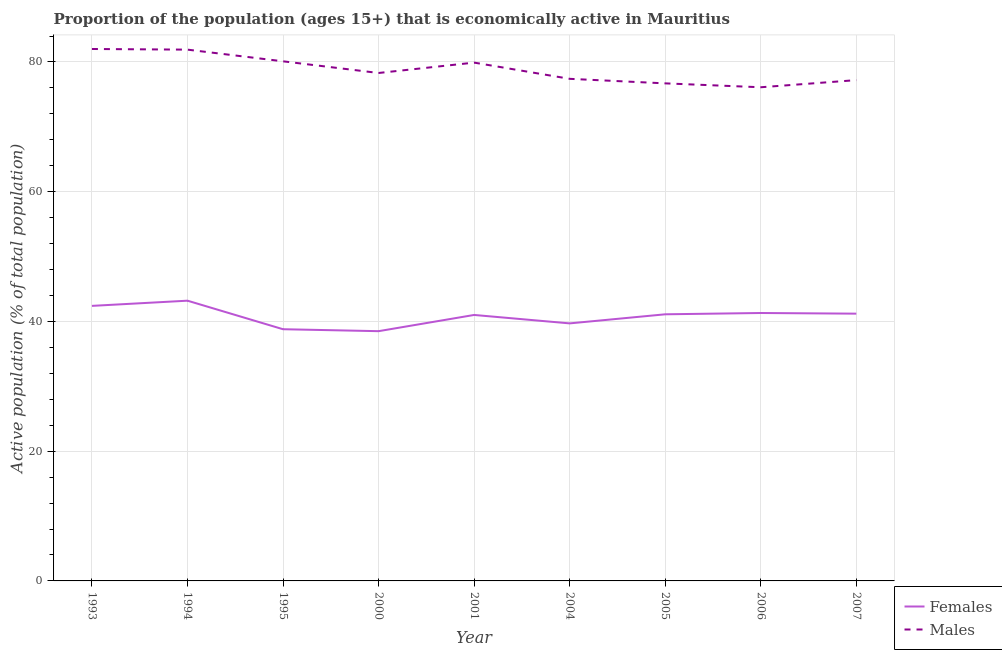How many different coloured lines are there?
Ensure brevity in your answer.  2. Is the number of lines equal to the number of legend labels?
Your response must be concise. Yes. Across all years, what is the minimum percentage of economically active male population?
Your answer should be very brief. 76.1. What is the total percentage of economically active male population in the graph?
Offer a very short reply. 709.6. What is the difference between the percentage of economically active female population in 1995 and that in 2001?
Give a very brief answer. -2.2. What is the difference between the percentage of economically active female population in 2004 and the percentage of economically active male population in 1995?
Your answer should be very brief. -40.4. What is the average percentage of economically active male population per year?
Provide a short and direct response. 78.84. In the year 2001, what is the difference between the percentage of economically active male population and percentage of economically active female population?
Offer a terse response. 38.9. In how many years, is the percentage of economically active male population greater than 40 %?
Your answer should be very brief. 9. What is the ratio of the percentage of economically active male population in 1994 to that in 2006?
Your answer should be compact. 1.08. What is the difference between the highest and the second highest percentage of economically active male population?
Your answer should be very brief. 0.1. What is the difference between the highest and the lowest percentage of economically active female population?
Make the answer very short. 4.7. Is the sum of the percentage of economically active male population in 2004 and 2007 greater than the maximum percentage of economically active female population across all years?
Your answer should be compact. Yes. Does the percentage of economically active male population monotonically increase over the years?
Offer a very short reply. No. Is the percentage of economically active female population strictly less than the percentage of economically active male population over the years?
Provide a short and direct response. Yes. How many lines are there?
Your answer should be compact. 2. Does the graph contain any zero values?
Provide a succinct answer. No. Does the graph contain grids?
Your answer should be compact. Yes. Where does the legend appear in the graph?
Provide a succinct answer. Bottom right. How many legend labels are there?
Your response must be concise. 2. What is the title of the graph?
Make the answer very short. Proportion of the population (ages 15+) that is economically active in Mauritius. What is the label or title of the X-axis?
Provide a succinct answer. Year. What is the label or title of the Y-axis?
Offer a very short reply. Active population (% of total population). What is the Active population (% of total population) in Females in 1993?
Give a very brief answer. 42.4. What is the Active population (% of total population) in Males in 1993?
Your answer should be very brief. 82. What is the Active population (% of total population) in Females in 1994?
Make the answer very short. 43.2. What is the Active population (% of total population) in Males in 1994?
Your answer should be very brief. 81.9. What is the Active population (% of total population) in Females in 1995?
Offer a very short reply. 38.8. What is the Active population (% of total population) in Males in 1995?
Provide a short and direct response. 80.1. What is the Active population (% of total population) of Females in 2000?
Make the answer very short. 38.5. What is the Active population (% of total population) of Males in 2000?
Your response must be concise. 78.3. What is the Active population (% of total population) in Females in 2001?
Your answer should be very brief. 41. What is the Active population (% of total population) of Males in 2001?
Give a very brief answer. 79.9. What is the Active population (% of total population) in Females in 2004?
Your answer should be compact. 39.7. What is the Active population (% of total population) of Males in 2004?
Your answer should be very brief. 77.4. What is the Active population (% of total population) of Females in 2005?
Keep it short and to the point. 41.1. What is the Active population (% of total population) of Males in 2005?
Offer a very short reply. 76.7. What is the Active population (% of total population) in Females in 2006?
Give a very brief answer. 41.3. What is the Active population (% of total population) of Males in 2006?
Give a very brief answer. 76.1. What is the Active population (% of total population) in Females in 2007?
Give a very brief answer. 41.2. What is the Active population (% of total population) in Males in 2007?
Offer a terse response. 77.2. Across all years, what is the maximum Active population (% of total population) of Females?
Make the answer very short. 43.2. Across all years, what is the minimum Active population (% of total population) of Females?
Ensure brevity in your answer.  38.5. Across all years, what is the minimum Active population (% of total population) in Males?
Make the answer very short. 76.1. What is the total Active population (% of total population) of Females in the graph?
Offer a terse response. 367.2. What is the total Active population (% of total population) of Males in the graph?
Keep it short and to the point. 709.6. What is the difference between the Active population (% of total population) of Males in 1993 and that in 1994?
Your answer should be very brief. 0.1. What is the difference between the Active population (% of total population) of Females in 1993 and that in 1995?
Offer a terse response. 3.6. What is the difference between the Active population (% of total population) in Males in 1993 and that in 1995?
Ensure brevity in your answer.  1.9. What is the difference between the Active population (% of total population) of Males in 1993 and that in 2000?
Your response must be concise. 3.7. What is the difference between the Active population (% of total population) of Males in 1993 and that in 2006?
Make the answer very short. 5.9. What is the difference between the Active population (% of total population) in Males in 1994 and that in 1995?
Keep it short and to the point. 1.8. What is the difference between the Active population (% of total population) of Females in 1994 and that in 2001?
Make the answer very short. 2.2. What is the difference between the Active population (% of total population) in Females in 1994 and that in 2004?
Your answer should be compact. 3.5. What is the difference between the Active population (% of total population) in Females in 1994 and that in 2007?
Give a very brief answer. 2. What is the difference between the Active population (% of total population) of Males in 1994 and that in 2007?
Offer a very short reply. 4.7. What is the difference between the Active population (% of total population) of Males in 1995 and that in 2001?
Offer a very short reply. 0.2. What is the difference between the Active population (% of total population) in Females in 1995 and that in 2004?
Provide a short and direct response. -0.9. What is the difference between the Active population (% of total population) in Males in 1995 and that in 2005?
Offer a terse response. 3.4. What is the difference between the Active population (% of total population) in Females in 1995 and that in 2006?
Your response must be concise. -2.5. What is the difference between the Active population (% of total population) of Males in 1995 and that in 2006?
Ensure brevity in your answer.  4. What is the difference between the Active population (% of total population) of Females in 2000 and that in 2004?
Keep it short and to the point. -1.2. What is the difference between the Active population (% of total population) of Males in 2000 and that in 2005?
Your answer should be very brief. 1.6. What is the difference between the Active population (% of total population) in Females in 2000 and that in 2006?
Your answer should be compact. -2.8. What is the difference between the Active population (% of total population) of Males in 2000 and that in 2006?
Offer a very short reply. 2.2. What is the difference between the Active population (% of total population) of Females in 2001 and that in 2004?
Provide a short and direct response. 1.3. What is the difference between the Active population (% of total population) of Males in 2001 and that in 2004?
Provide a short and direct response. 2.5. What is the difference between the Active population (% of total population) of Females in 2001 and that in 2005?
Offer a very short reply. -0.1. What is the difference between the Active population (% of total population) of Males in 2001 and that in 2006?
Provide a succinct answer. 3.8. What is the difference between the Active population (% of total population) in Females in 2001 and that in 2007?
Offer a terse response. -0.2. What is the difference between the Active population (% of total population) in Males in 2001 and that in 2007?
Provide a short and direct response. 2.7. What is the difference between the Active population (% of total population) in Females in 2004 and that in 2007?
Offer a terse response. -1.5. What is the difference between the Active population (% of total population) in Males in 2004 and that in 2007?
Keep it short and to the point. 0.2. What is the difference between the Active population (% of total population) of Females in 2005 and that in 2006?
Give a very brief answer. -0.2. What is the difference between the Active population (% of total population) in Females in 2005 and that in 2007?
Keep it short and to the point. -0.1. What is the difference between the Active population (% of total population) of Females in 1993 and the Active population (% of total population) of Males in 1994?
Make the answer very short. -39.5. What is the difference between the Active population (% of total population) of Females in 1993 and the Active population (% of total population) of Males in 1995?
Keep it short and to the point. -37.7. What is the difference between the Active population (% of total population) of Females in 1993 and the Active population (% of total population) of Males in 2000?
Your response must be concise. -35.9. What is the difference between the Active population (% of total population) of Females in 1993 and the Active population (% of total population) of Males in 2001?
Provide a short and direct response. -37.5. What is the difference between the Active population (% of total population) of Females in 1993 and the Active population (% of total population) of Males in 2004?
Offer a terse response. -35. What is the difference between the Active population (% of total population) in Females in 1993 and the Active population (% of total population) in Males in 2005?
Keep it short and to the point. -34.3. What is the difference between the Active population (% of total population) in Females in 1993 and the Active population (% of total population) in Males in 2006?
Ensure brevity in your answer.  -33.7. What is the difference between the Active population (% of total population) in Females in 1993 and the Active population (% of total population) in Males in 2007?
Your response must be concise. -34.8. What is the difference between the Active population (% of total population) of Females in 1994 and the Active population (% of total population) of Males in 1995?
Offer a terse response. -36.9. What is the difference between the Active population (% of total population) in Females in 1994 and the Active population (% of total population) in Males in 2000?
Make the answer very short. -35.1. What is the difference between the Active population (% of total population) in Females in 1994 and the Active population (% of total population) in Males in 2001?
Your answer should be compact. -36.7. What is the difference between the Active population (% of total population) of Females in 1994 and the Active population (% of total population) of Males in 2004?
Give a very brief answer. -34.2. What is the difference between the Active population (% of total population) of Females in 1994 and the Active population (% of total population) of Males in 2005?
Your answer should be compact. -33.5. What is the difference between the Active population (% of total population) of Females in 1994 and the Active population (% of total population) of Males in 2006?
Give a very brief answer. -32.9. What is the difference between the Active population (% of total population) of Females in 1994 and the Active population (% of total population) of Males in 2007?
Provide a short and direct response. -34. What is the difference between the Active population (% of total population) of Females in 1995 and the Active population (% of total population) of Males in 2000?
Give a very brief answer. -39.5. What is the difference between the Active population (% of total population) in Females in 1995 and the Active population (% of total population) in Males in 2001?
Provide a short and direct response. -41.1. What is the difference between the Active population (% of total population) of Females in 1995 and the Active population (% of total population) of Males in 2004?
Offer a terse response. -38.6. What is the difference between the Active population (% of total population) in Females in 1995 and the Active population (% of total population) in Males in 2005?
Your answer should be compact. -37.9. What is the difference between the Active population (% of total population) in Females in 1995 and the Active population (% of total population) in Males in 2006?
Your answer should be compact. -37.3. What is the difference between the Active population (% of total population) of Females in 1995 and the Active population (% of total population) of Males in 2007?
Your answer should be very brief. -38.4. What is the difference between the Active population (% of total population) in Females in 2000 and the Active population (% of total population) in Males in 2001?
Keep it short and to the point. -41.4. What is the difference between the Active population (% of total population) of Females in 2000 and the Active population (% of total population) of Males in 2004?
Ensure brevity in your answer.  -38.9. What is the difference between the Active population (% of total population) in Females in 2000 and the Active population (% of total population) in Males in 2005?
Offer a very short reply. -38.2. What is the difference between the Active population (% of total population) of Females in 2000 and the Active population (% of total population) of Males in 2006?
Keep it short and to the point. -37.6. What is the difference between the Active population (% of total population) of Females in 2000 and the Active population (% of total population) of Males in 2007?
Your response must be concise. -38.7. What is the difference between the Active population (% of total population) in Females in 2001 and the Active population (% of total population) in Males in 2004?
Offer a very short reply. -36.4. What is the difference between the Active population (% of total population) of Females in 2001 and the Active population (% of total population) of Males in 2005?
Your answer should be compact. -35.7. What is the difference between the Active population (% of total population) in Females in 2001 and the Active population (% of total population) in Males in 2006?
Your answer should be very brief. -35.1. What is the difference between the Active population (% of total population) of Females in 2001 and the Active population (% of total population) of Males in 2007?
Offer a terse response. -36.2. What is the difference between the Active population (% of total population) in Females in 2004 and the Active population (% of total population) in Males in 2005?
Keep it short and to the point. -37. What is the difference between the Active population (% of total population) in Females in 2004 and the Active population (% of total population) in Males in 2006?
Keep it short and to the point. -36.4. What is the difference between the Active population (% of total population) of Females in 2004 and the Active population (% of total population) of Males in 2007?
Your answer should be very brief. -37.5. What is the difference between the Active population (% of total population) of Females in 2005 and the Active population (% of total population) of Males in 2006?
Your answer should be very brief. -35. What is the difference between the Active population (% of total population) of Females in 2005 and the Active population (% of total population) of Males in 2007?
Keep it short and to the point. -36.1. What is the difference between the Active population (% of total population) in Females in 2006 and the Active population (% of total population) in Males in 2007?
Make the answer very short. -35.9. What is the average Active population (% of total population) in Females per year?
Offer a very short reply. 40.8. What is the average Active population (% of total population) in Males per year?
Your answer should be very brief. 78.84. In the year 1993, what is the difference between the Active population (% of total population) of Females and Active population (% of total population) of Males?
Your answer should be very brief. -39.6. In the year 1994, what is the difference between the Active population (% of total population) of Females and Active population (% of total population) of Males?
Keep it short and to the point. -38.7. In the year 1995, what is the difference between the Active population (% of total population) in Females and Active population (% of total population) in Males?
Your response must be concise. -41.3. In the year 2000, what is the difference between the Active population (% of total population) of Females and Active population (% of total population) of Males?
Provide a short and direct response. -39.8. In the year 2001, what is the difference between the Active population (% of total population) in Females and Active population (% of total population) in Males?
Offer a very short reply. -38.9. In the year 2004, what is the difference between the Active population (% of total population) in Females and Active population (% of total population) in Males?
Your answer should be very brief. -37.7. In the year 2005, what is the difference between the Active population (% of total population) in Females and Active population (% of total population) in Males?
Offer a terse response. -35.6. In the year 2006, what is the difference between the Active population (% of total population) in Females and Active population (% of total population) in Males?
Offer a terse response. -34.8. In the year 2007, what is the difference between the Active population (% of total population) in Females and Active population (% of total population) in Males?
Offer a very short reply. -36. What is the ratio of the Active population (% of total population) of Females in 1993 to that in 1994?
Give a very brief answer. 0.98. What is the ratio of the Active population (% of total population) in Females in 1993 to that in 1995?
Provide a short and direct response. 1.09. What is the ratio of the Active population (% of total population) of Males in 1993 to that in 1995?
Provide a succinct answer. 1.02. What is the ratio of the Active population (% of total population) of Females in 1993 to that in 2000?
Your answer should be compact. 1.1. What is the ratio of the Active population (% of total population) of Males in 1993 to that in 2000?
Offer a very short reply. 1.05. What is the ratio of the Active population (% of total population) of Females in 1993 to that in 2001?
Offer a terse response. 1.03. What is the ratio of the Active population (% of total population) of Males in 1993 to that in 2001?
Your answer should be compact. 1.03. What is the ratio of the Active population (% of total population) of Females in 1993 to that in 2004?
Provide a succinct answer. 1.07. What is the ratio of the Active population (% of total population) in Males in 1993 to that in 2004?
Provide a succinct answer. 1.06. What is the ratio of the Active population (% of total population) in Females in 1993 to that in 2005?
Offer a terse response. 1.03. What is the ratio of the Active population (% of total population) of Males in 1993 to that in 2005?
Offer a terse response. 1.07. What is the ratio of the Active population (% of total population) in Females in 1993 to that in 2006?
Keep it short and to the point. 1.03. What is the ratio of the Active population (% of total population) of Males in 1993 to that in 2006?
Your response must be concise. 1.08. What is the ratio of the Active population (% of total population) of Females in 1993 to that in 2007?
Your answer should be compact. 1.03. What is the ratio of the Active population (% of total population) of Males in 1993 to that in 2007?
Ensure brevity in your answer.  1.06. What is the ratio of the Active population (% of total population) in Females in 1994 to that in 1995?
Provide a short and direct response. 1.11. What is the ratio of the Active population (% of total population) in Males in 1994 to that in 1995?
Your answer should be compact. 1.02. What is the ratio of the Active population (% of total population) of Females in 1994 to that in 2000?
Provide a short and direct response. 1.12. What is the ratio of the Active population (% of total population) in Males in 1994 to that in 2000?
Give a very brief answer. 1.05. What is the ratio of the Active population (% of total population) of Females in 1994 to that in 2001?
Your response must be concise. 1.05. What is the ratio of the Active population (% of total population) in Males in 1994 to that in 2001?
Your answer should be compact. 1.02. What is the ratio of the Active population (% of total population) in Females in 1994 to that in 2004?
Provide a succinct answer. 1.09. What is the ratio of the Active population (% of total population) in Males in 1994 to that in 2004?
Your response must be concise. 1.06. What is the ratio of the Active population (% of total population) of Females in 1994 to that in 2005?
Your answer should be compact. 1.05. What is the ratio of the Active population (% of total population) in Males in 1994 to that in 2005?
Give a very brief answer. 1.07. What is the ratio of the Active population (% of total population) of Females in 1994 to that in 2006?
Offer a very short reply. 1.05. What is the ratio of the Active population (% of total population) in Males in 1994 to that in 2006?
Make the answer very short. 1.08. What is the ratio of the Active population (% of total population) in Females in 1994 to that in 2007?
Provide a short and direct response. 1.05. What is the ratio of the Active population (% of total population) in Males in 1994 to that in 2007?
Ensure brevity in your answer.  1.06. What is the ratio of the Active population (% of total population) of Females in 1995 to that in 2000?
Keep it short and to the point. 1.01. What is the ratio of the Active population (% of total population) of Females in 1995 to that in 2001?
Provide a short and direct response. 0.95. What is the ratio of the Active population (% of total population) in Males in 1995 to that in 2001?
Provide a short and direct response. 1. What is the ratio of the Active population (% of total population) in Females in 1995 to that in 2004?
Your answer should be very brief. 0.98. What is the ratio of the Active population (% of total population) in Males in 1995 to that in 2004?
Provide a short and direct response. 1.03. What is the ratio of the Active population (% of total population) of Females in 1995 to that in 2005?
Your answer should be very brief. 0.94. What is the ratio of the Active population (% of total population) in Males in 1995 to that in 2005?
Make the answer very short. 1.04. What is the ratio of the Active population (% of total population) in Females in 1995 to that in 2006?
Give a very brief answer. 0.94. What is the ratio of the Active population (% of total population) in Males in 1995 to that in 2006?
Offer a very short reply. 1.05. What is the ratio of the Active population (% of total population) in Females in 1995 to that in 2007?
Keep it short and to the point. 0.94. What is the ratio of the Active population (% of total population) of Males in 1995 to that in 2007?
Offer a very short reply. 1.04. What is the ratio of the Active population (% of total population) in Females in 2000 to that in 2001?
Provide a short and direct response. 0.94. What is the ratio of the Active population (% of total population) of Males in 2000 to that in 2001?
Your response must be concise. 0.98. What is the ratio of the Active population (% of total population) in Females in 2000 to that in 2004?
Offer a terse response. 0.97. What is the ratio of the Active population (% of total population) of Males in 2000 to that in 2004?
Keep it short and to the point. 1.01. What is the ratio of the Active population (% of total population) of Females in 2000 to that in 2005?
Offer a very short reply. 0.94. What is the ratio of the Active population (% of total population) in Males in 2000 to that in 2005?
Ensure brevity in your answer.  1.02. What is the ratio of the Active population (% of total population) in Females in 2000 to that in 2006?
Make the answer very short. 0.93. What is the ratio of the Active population (% of total population) of Males in 2000 to that in 2006?
Provide a short and direct response. 1.03. What is the ratio of the Active population (% of total population) in Females in 2000 to that in 2007?
Ensure brevity in your answer.  0.93. What is the ratio of the Active population (% of total population) of Males in 2000 to that in 2007?
Your response must be concise. 1.01. What is the ratio of the Active population (% of total population) of Females in 2001 to that in 2004?
Provide a succinct answer. 1.03. What is the ratio of the Active population (% of total population) of Males in 2001 to that in 2004?
Offer a very short reply. 1.03. What is the ratio of the Active population (% of total population) in Females in 2001 to that in 2005?
Give a very brief answer. 1. What is the ratio of the Active population (% of total population) in Males in 2001 to that in 2005?
Keep it short and to the point. 1.04. What is the ratio of the Active population (% of total population) in Females in 2001 to that in 2006?
Make the answer very short. 0.99. What is the ratio of the Active population (% of total population) of Males in 2001 to that in 2006?
Provide a short and direct response. 1.05. What is the ratio of the Active population (% of total population) in Males in 2001 to that in 2007?
Ensure brevity in your answer.  1.03. What is the ratio of the Active population (% of total population) in Females in 2004 to that in 2005?
Offer a very short reply. 0.97. What is the ratio of the Active population (% of total population) of Males in 2004 to that in 2005?
Offer a very short reply. 1.01. What is the ratio of the Active population (% of total population) of Females in 2004 to that in 2006?
Your answer should be compact. 0.96. What is the ratio of the Active population (% of total population) of Males in 2004 to that in 2006?
Ensure brevity in your answer.  1.02. What is the ratio of the Active population (% of total population) in Females in 2004 to that in 2007?
Your answer should be very brief. 0.96. What is the ratio of the Active population (% of total population) in Males in 2004 to that in 2007?
Give a very brief answer. 1. What is the ratio of the Active population (% of total population) in Males in 2005 to that in 2006?
Ensure brevity in your answer.  1.01. What is the ratio of the Active population (% of total population) of Females in 2005 to that in 2007?
Provide a short and direct response. 1. What is the ratio of the Active population (% of total population) in Males in 2005 to that in 2007?
Keep it short and to the point. 0.99. What is the ratio of the Active population (% of total population) of Females in 2006 to that in 2007?
Keep it short and to the point. 1. What is the ratio of the Active population (% of total population) of Males in 2006 to that in 2007?
Ensure brevity in your answer.  0.99. What is the difference between the highest and the second highest Active population (% of total population) of Females?
Give a very brief answer. 0.8. What is the difference between the highest and the second highest Active population (% of total population) in Males?
Your answer should be compact. 0.1. What is the difference between the highest and the lowest Active population (% of total population) in Females?
Your response must be concise. 4.7. What is the difference between the highest and the lowest Active population (% of total population) in Males?
Ensure brevity in your answer.  5.9. 